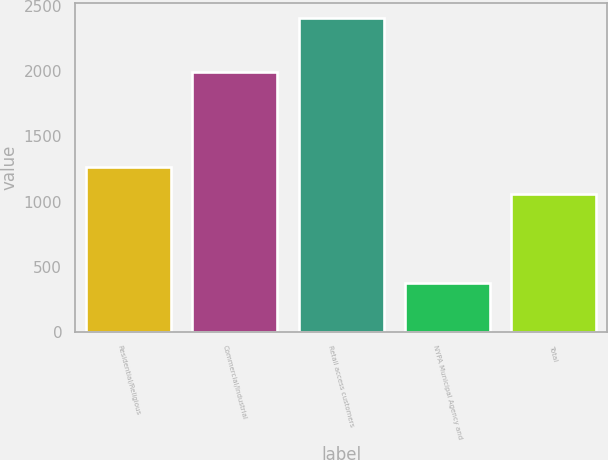<chart> <loc_0><loc_0><loc_500><loc_500><bar_chart><fcel>Residential/Religious<fcel>Commercial/Industrial<fcel>Retail access customers<fcel>NYPA Municipal Agency and<fcel>Total<nl><fcel>1263.3<fcel>1993<fcel>2408<fcel>375<fcel>1060<nl></chart> 